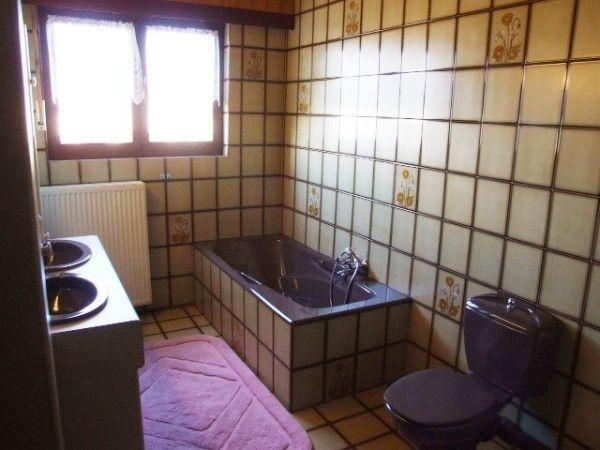What happens in this room? bathing 